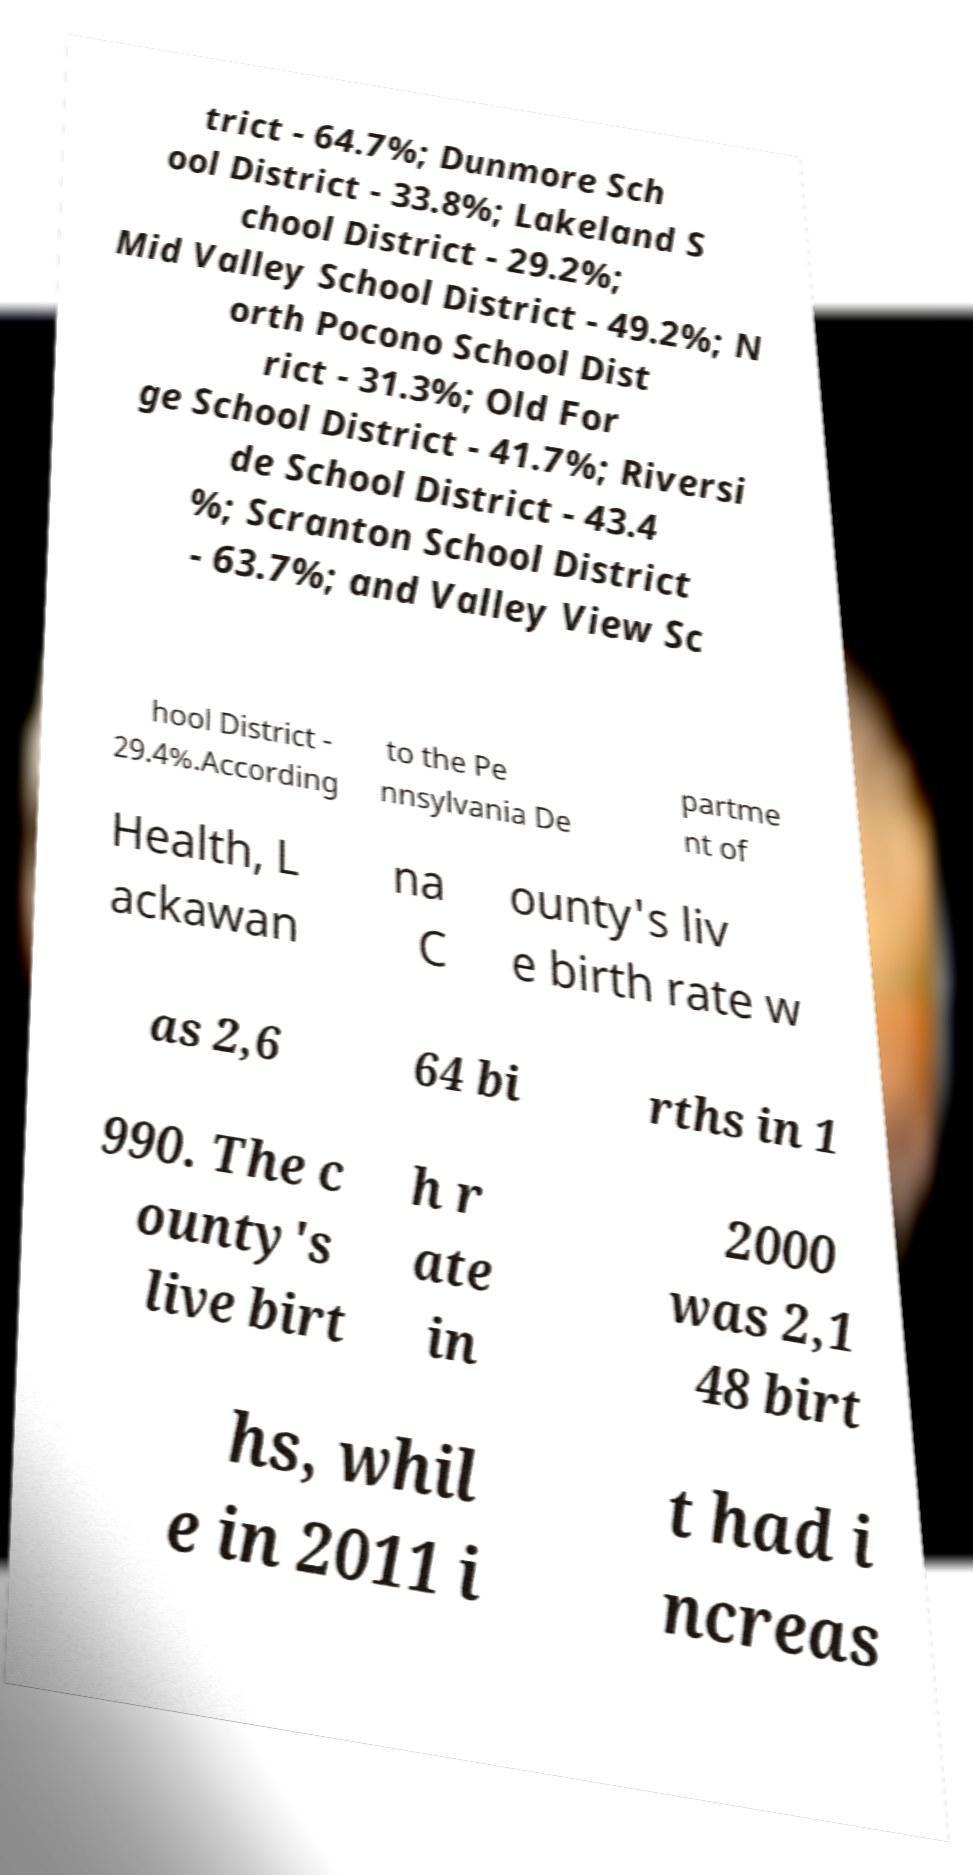I need the written content from this picture converted into text. Can you do that? trict - 64.7%; Dunmore Sch ool District - 33.8%; Lakeland S chool District - 29.2%; Mid Valley School District - 49.2%; N orth Pocono School Dist rict - 31.3%; Old For ge School District - 41.7%; Riversi de School District - 43.4 %; Scranton School District - 63.7%; and Valley View Sc hool District - 29.4%.According to the Pe nnsylvania De partme nt of Health, L ackawan na C ounty's liv e birth rate w as 2,6 64 bi rths in 1 990. The c ounty's live birt h r ate in 2000 was 2,1 48 birt hs, whil e in 2011 i t had i ncreas 